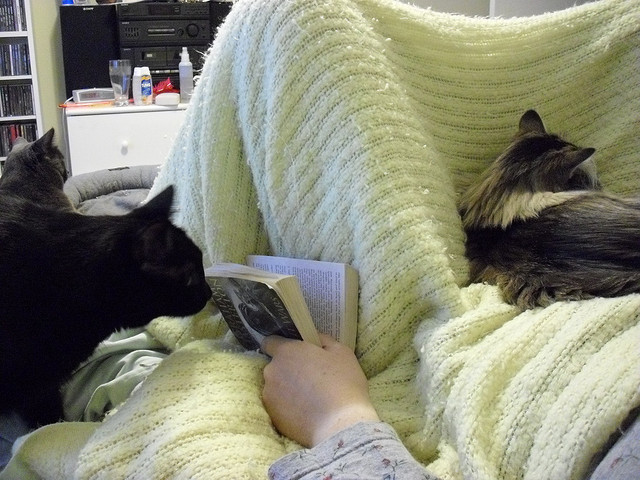Describe the atmosphere of the room where the person and the cats are. The room exudes a sense of tranquility and comfort, accentuated by the soft glow of the natural light and the casual arrangement of items. The presence of a bookshelf and the electronic equipment suggests a living space designed for relaxation and personal interests such as reading, listening to music, or perhaps watching television. Is there anything that indicates the time of day or season in the image? While the image doesn't provide a direct indication of the time of day or season, the soft lighting and the choice of a snug blanket might imply it's during a cooler part of the day or year, possibly an evening or during fall or winter when the comforting warmth of a blanket and the company of pets is most welcome. 